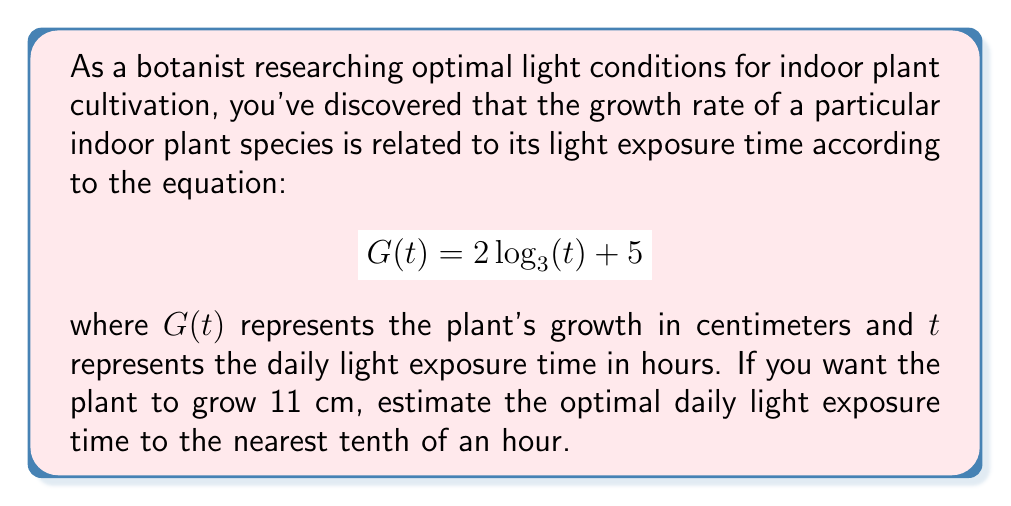Teach me how to tackle this problem. To solve this problem, we need to follow these steps:

1) We're given the equation $G(t) = 2\log_3(t) + 5$, and we want to find $t$ when $G(t) = 11$.

2) Let's substitute $G(t) = 11$ into the equation:

   $11 = 2\log_3(t) + 5$

3) Subtract 5 from both sides:

   $6 = 2\log_3(t)$

4) Divide both sides by 2:

   $3 = \log_3(t)$

5) Now, we need to solve for $t$. Remember, if $\log_b(x) = y$, then $b^y = x$. So:

   $3^3 = t$

6) Calculate:

   $27 = t$

Therefore, the optimal daily light exposure time is 27 hours. However, since we need to estimate to the nearest tenth of an hour, our final answer is 27.0 hours.
Answer: 27.0 hours 